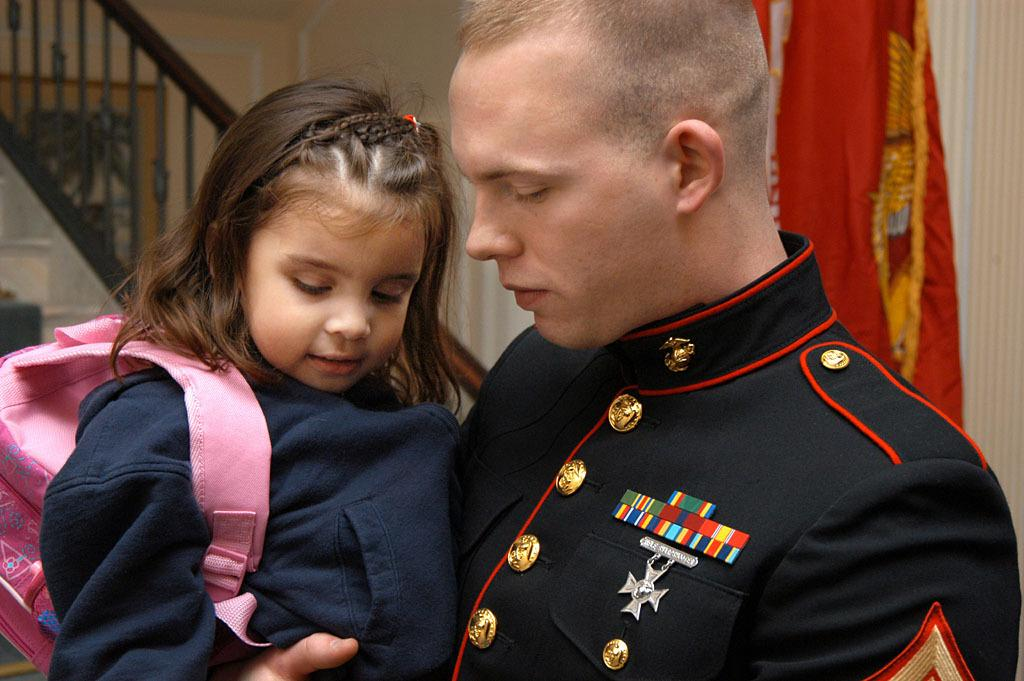What is the person in the image doing? The person is standing and holding a baby. What can be seen in the background of the image? There is a staircase, a flag, and a wall in the background of the image. What type of bun is the baby wearing in the image? There is no bun visible on the baby in the image. Is the person holding the baby the baby's father in the image? The relationship between the person holding the baby and the baby cannot be determined from the image alone. 